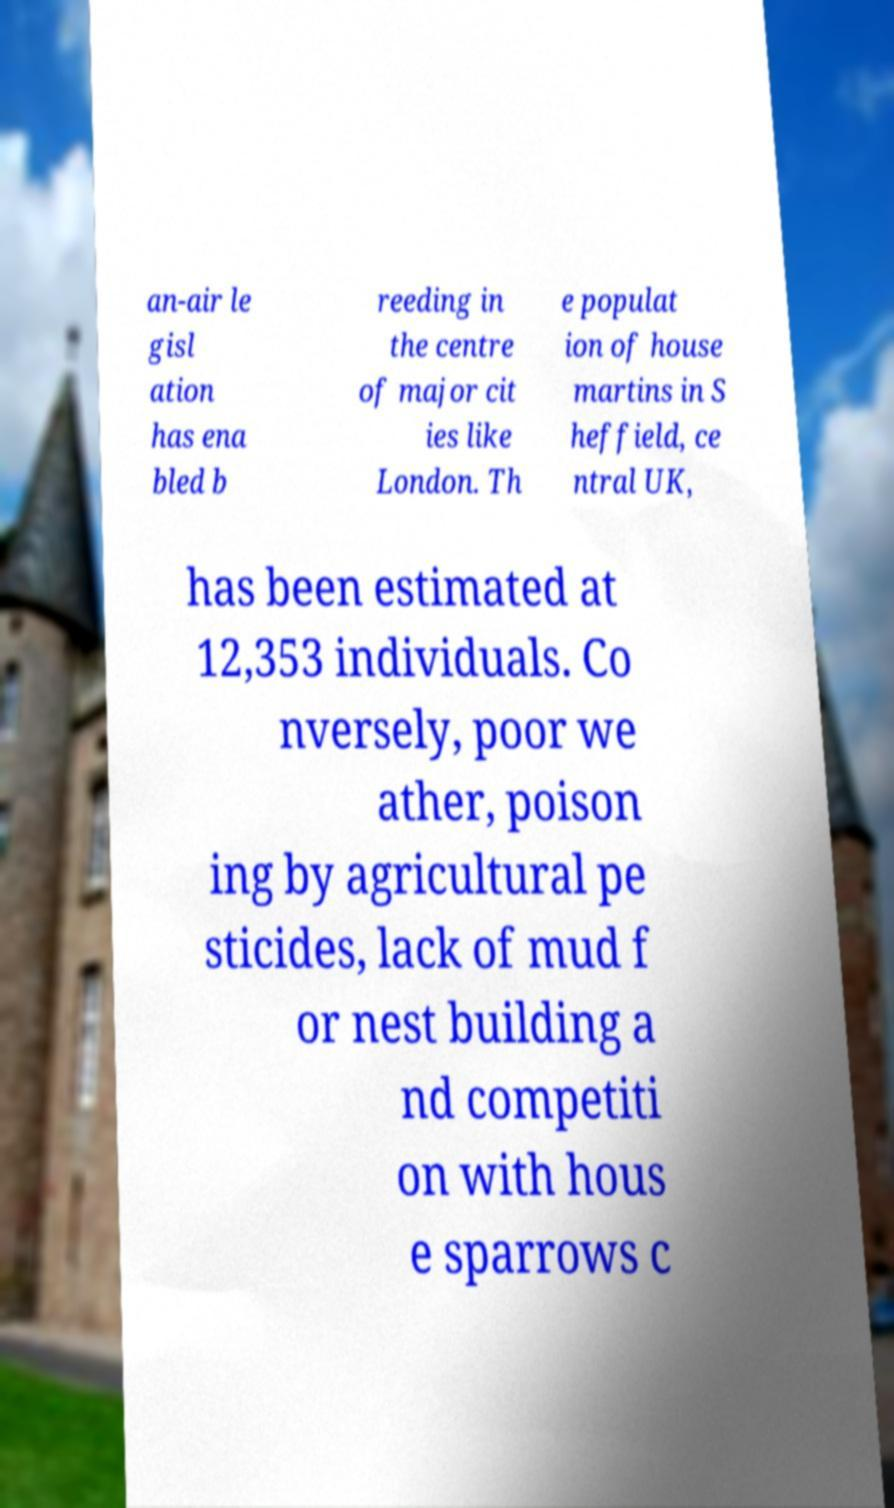I need the written content from this picture converted into text. Can you do that? an-air le gisl ation has ena bled b reeding in the centre of major cit ies like London. Th e populat ion of house martins in S heffield, ce ntral UK, has been estimated at 12,353 individuals. Co nversely, poor we ather, poison ing by agricultural pe sticides, lack of mud f or nest building a nd competiti on with hous e sparrows c 